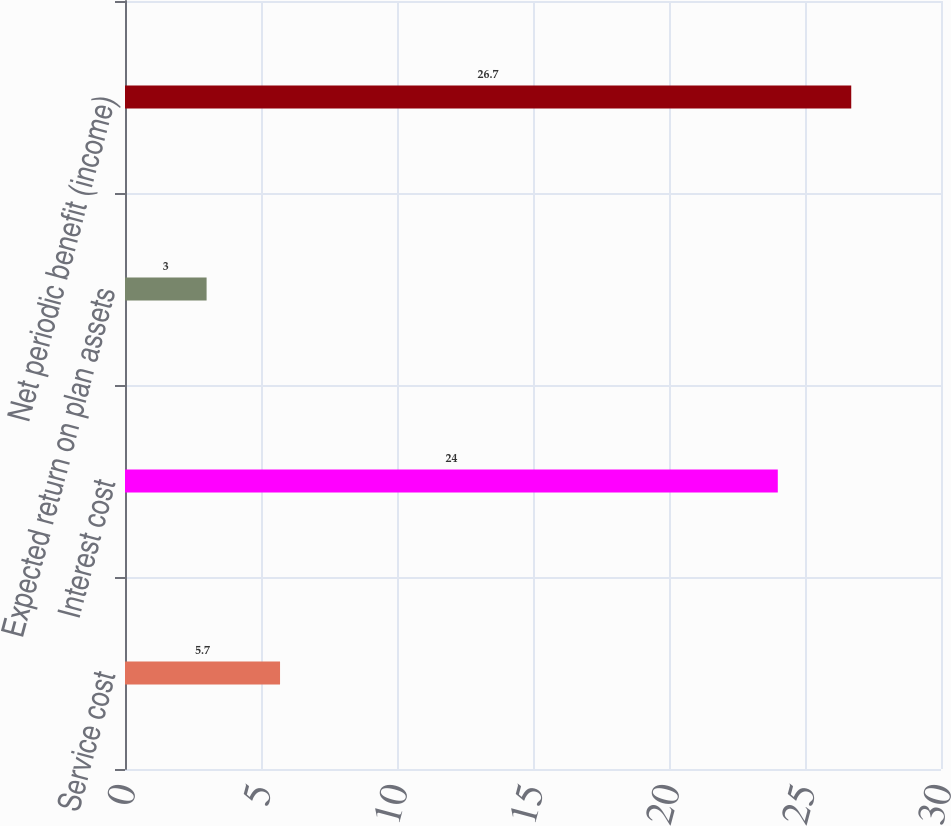Convert chart. <chart><loc_0><loc_0><loc_500><loc_500><bar_chart><fcel>Service cost<fcel>Interest cost<fcel>Expected return on plan assets<fcel>Net periodic benefit (income)<nl><fcel>5.7<fcel>24<fcel>3<fcel>26.7<nl></chart> 